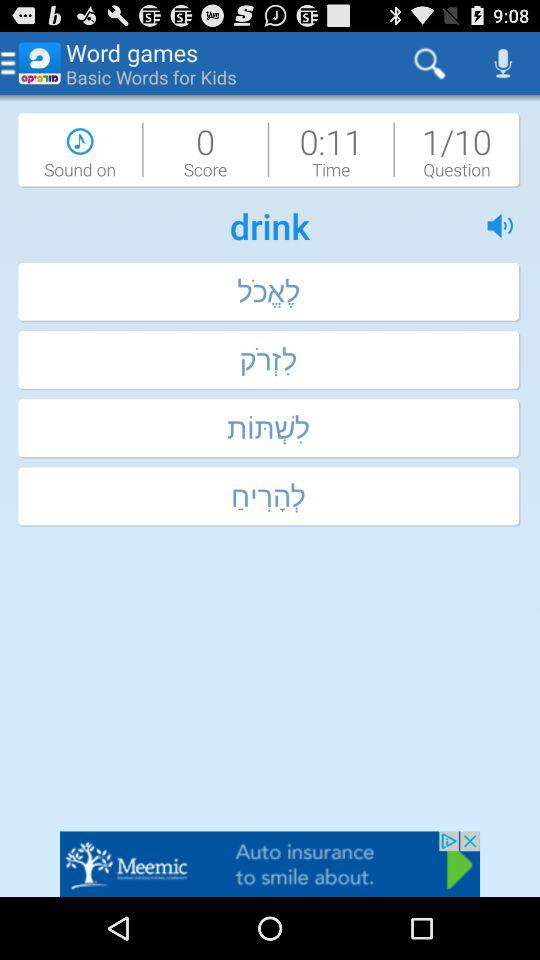What is the total number of questions? The total number of questions is 10. 